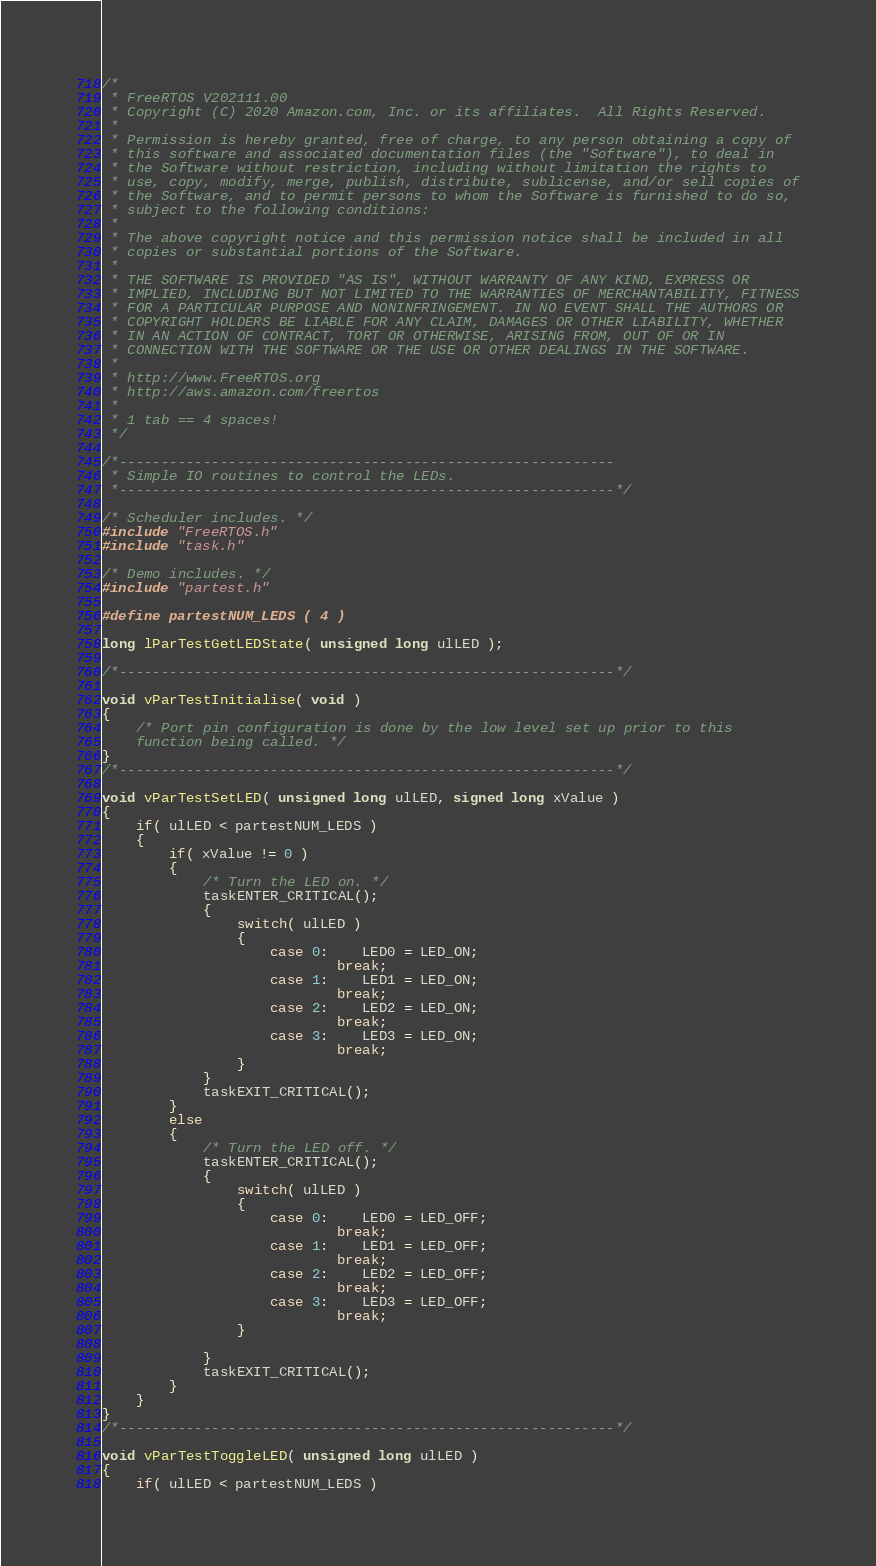Convert code to text. <code><loc_0><loc_0><loc_500><loc_500><_C_>/*
 * FreeRTOS V202111.00
 * Copyright (C) 2020 Amazon.com, Inc. or its affiliates.  All Rights Reserved.
 *
 * Permission is hereby granted, free of charge, to any person obtaining a copy of
 * this software and associated documentation files (the "Software"), to deal in
 * the Software without restriction, including without limitation the rights to
 * use, copy, modify, merge, publish, distribute, sublicense, and/or sell copies of
 * the Software, and to permit persons to whom the Software is furnished to do so,
 * subject to the following conditions:
 *
 * The above copyright notice and this permission notice shall be included in all
 * copies or substantial portions of the Software.
 *
 * THE SOFTWARE IS PROVIDED "AS IS", WITHOUT WARRANTY OF ANY KIND, EXPRESS OR
 * IMPLIED, INCLUDING BUT NOT LIMITED TO THE WARRANTIES OF MERCHANTABILITY, FITNESS
 * FOR A PARTICULAR PURPOSE AND NONINFRINGEMENT. IN NO EVENT SHALL THE AUTHORS OR
 * COPYRIGHT HOLDERS BE LIABLE FOR ANY CLAIM, DAMAGES OR OTHER LIABILITY, WHETHER
 * IN AN ACTION OF CONTRACT, TORT OR OTHERWISE, ARISING FROM, OUT OF OR IN
 * CONNECTION WITH THE SOFTWARE OR THE USE OR OTHER DEALINGS IN THE SOFTWARE.
 *
 * http://www.FreeRTOS.org
 * http://aws.amazon.com/freertos
 *
 * 1 tab == 4 spaces!
 */

/*-----------------------------------------------------------
 * Simple IO routines to control the LEDs.
 *-----------------------------------------------------------*/

/* Scheduler includes. */
#include "FreeRTOS.h"
#include "task.h"

/* Demo includes. */
#include "partest.h"

#define partestNUM_LEDS ( 4 )

long lParTestGetLEDState( unsigned long ulLED );

/*-----------------------------------------------------------*/

void vParTestInitialise( void )
{
	/* Port pin configuration is done by the low level set up prior to this
	function being called. */
}
/*-----------------------------------------------------------*/

void vParTestSetLED( unsigned long ulLED, signed long xValue )
{
	if( ulLED < partestNUM_LEDS )
	{
		if( xValue != 0 )
		{
			/* Turn the LED on. */
			taskENTER_CRITICAL();
			{
				switch( ulLED )
				{
					case 0:	LED0 = LED_ON;
							break;
					case 1:	LED1 = LED_ON;
							break;
					case 2:	LED2 = LED_ON;
							break;
					case 3:	LED3 = LED_ON;
							break;
				}
			}
			taskEXIT_CRITICAL();
		}
		else
		{
			/* Turn the LED off. */
			taskENTER_CRITICAL();
			{
				switch( ulLED )
				{
					case 0:	LED0 = LED_OFF;
							break;
					case 1:	LED1 = LED_OFF;
							break;
					case 2:	LED2 = LED_OFF;
							break;
					case 3:	LED3 = LED_OFF;
							break;
				}

			}
			taskEXIT_CRITICAL();
		}
	}
}
/*-----------------------------------------------------------*/

void vParTestToggleLED( unsigned long ulLED )
{
	if( ulLED < partestNUM_LEDS )</code> 